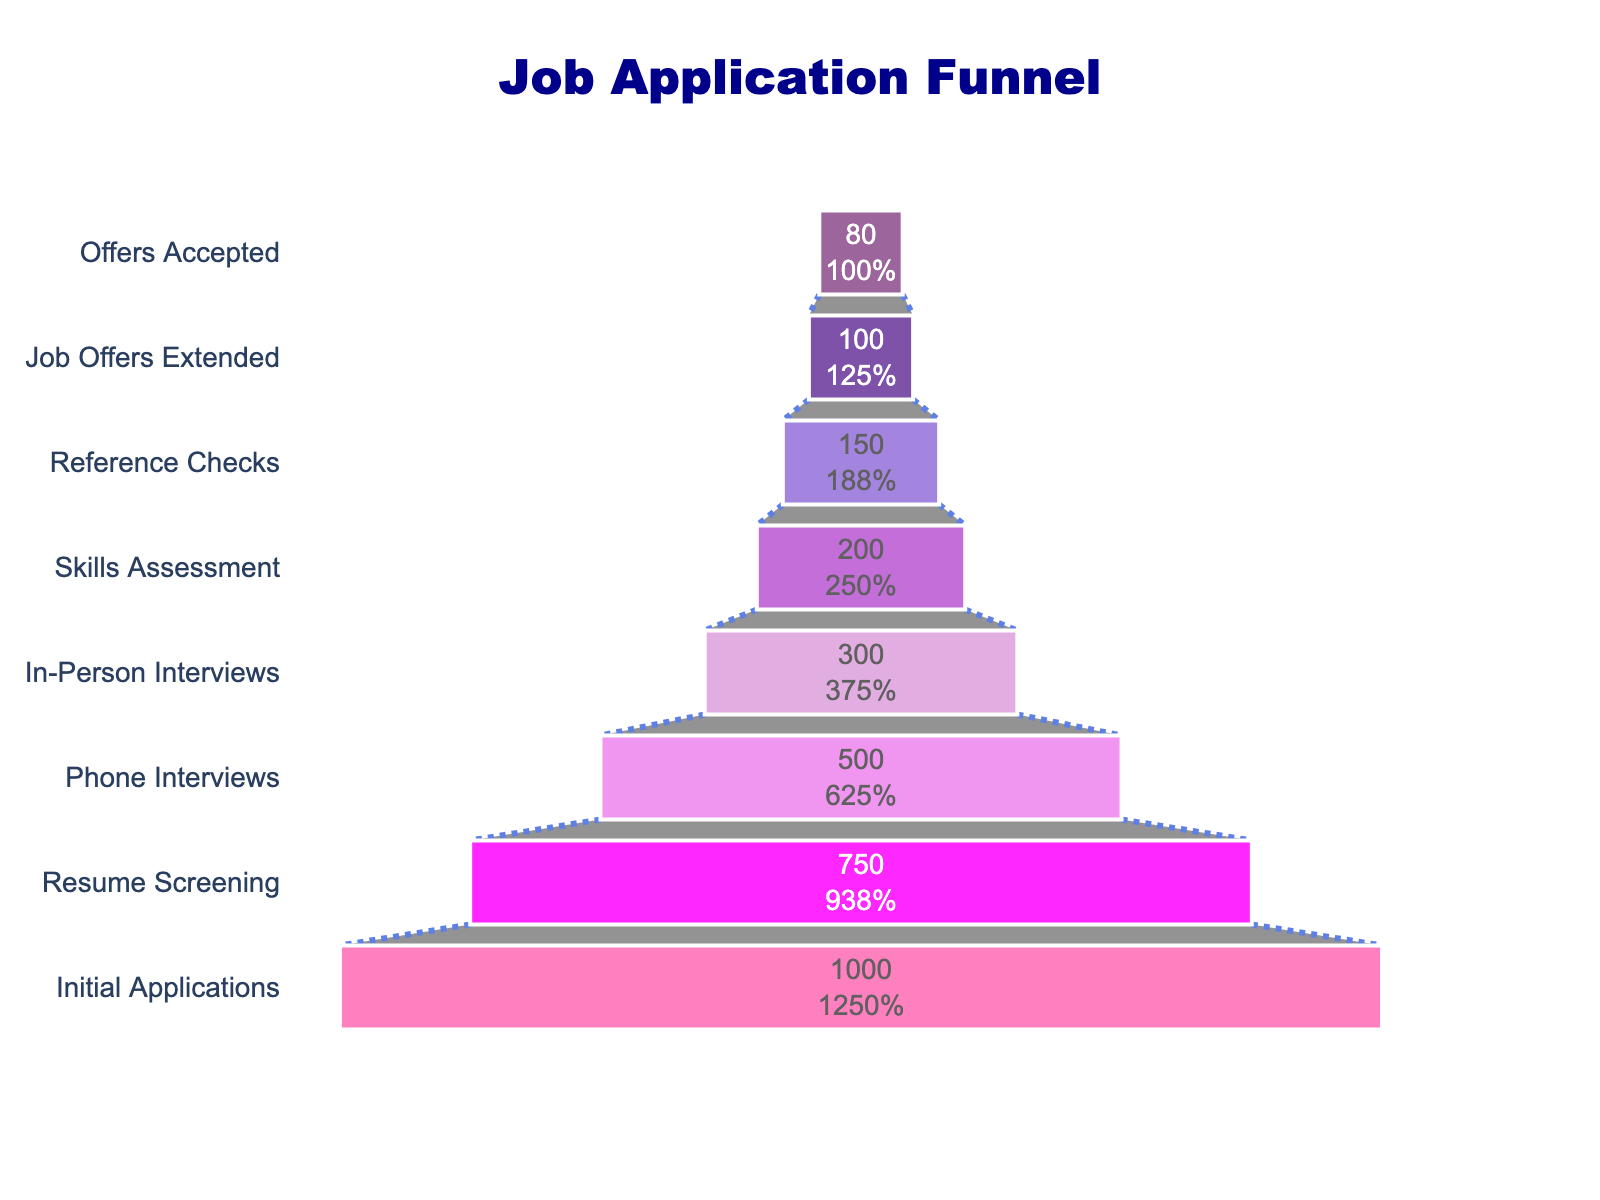How many stages are there in the job application process? The chart lists all the stages in the job application process. By counting the distinct bars shown, we can determine the number of stages.
Answer: 8 What percentage of initial applicants make it to the Skills Assessment stage? The initial number of applicants is 1000, and by the Skills Assessment stage, there are 200 applicants. The percentage is calculated as (200/1000) * 100 = 20%.
Answer: 20% Which stage experiences the highest drop-off rate in the number of applicants? To determine the largest drop-off, we need to compare the decrease in the number of applicants between consecutive stages. The biggest drop occurs between Initial Applications (1000) and Resume Screening (750), a drop of 250.
Answer: Resume Screening How many applicants are filtered out between the Reference Checks and Job Offers Extended stages? The number of applicants in the Reference Checks stage is 150, and in the Job Offers Extended stage is 100. The difference is 150 - 100 = 50.
Answer: 50 What proportion of applicants who receive a job offer accept it? The number of job offers is 100, and the number of accepted offers is 80. The proportion is (80/100) = 0.8, or 80%.
Answer: 80% Compare the number of applicants who pass the Phone Interviews stage to those who make it through In-Person Interviews. How many more or fewer are there? There are 500 applicants in the Phone Interviews stage and 300 in the In-Person Interviews stage. The difference is 500 - 300 = 200.
Answer: 200 fewer At which stage do less than half of the original applicants remain? Starting from 1000 applicants, we identify the first stage where less than half (less than 500) of the original group remains. This happens at the In-Person Interviews stage (300 applicants).
Answer: In-Person Interviews What percentage of applicants move from Resume Screening to Phone Interviews? The number of applicants in Resume Screening is 750, and in Phone Interviews is 500. The percentage is calculated as (500/750) * 100 = 66.67%.
Answer: 66.67% How many stages have more than 50% of applicants dropped out by the end of that stage? Tracking each stage from the beginning: Resume Screening (1000 to 750, less than 50% drop), Phone Interviews (750 to 500, less than 50% drop), In-Person Interviews (500 to 300, more than 50% drop), means three stages (Skills Assessment, Reference Checks, Job Offers Extended) onwards also have more than 50% drop by the end. Totaling this, there are 5 stages.
Answer: 5 stages What is the average drop-off rate per stage from Initial Applications to Offers Accepted? To find the average drop-off rate, sum the drop-off in each stage and divide by the number of stages. Drops are 250 (1000-750), 250 (750-500), 200 (500-300), 100 (300-200), 50 (200-150), 50 (150-100), 20 (100-80). Sum = 920; there are 7 transitions, so average = 920/7 ≈ 131.43.
Answer: 131.43 